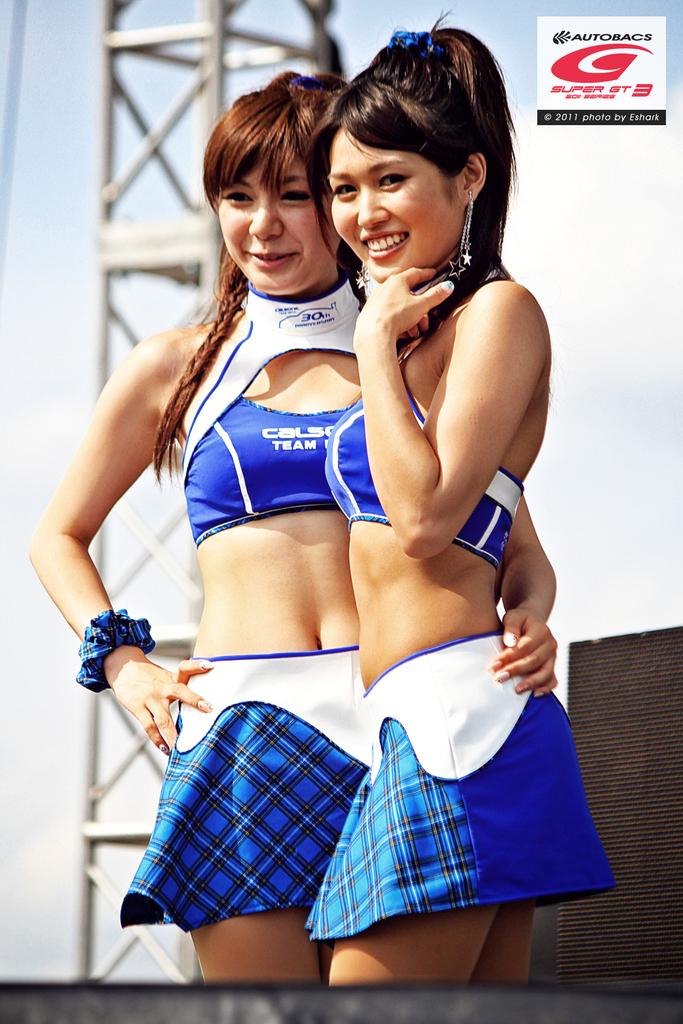What is the team name on the woman's uniform?
Offer a terse response. Unanswerable. What company has an ad at the top?
Provide a succinct answer. Autobacs. 